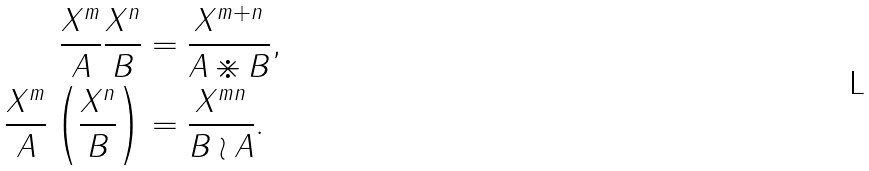<formula> <loc_0><loc_0><loc_500><loc_500>\frac { X ^ { m } } { A } \frac { X ^ { n } } { B } & = \frac { X ^ { m + n } } { A \divideontimes B } , \\ \frac { X ^ { m } } { A } \left ( \frac { X ^ { n } } { B } \right ) & = \frac { X ^ { m n } } { B \wr A } .</formula> 